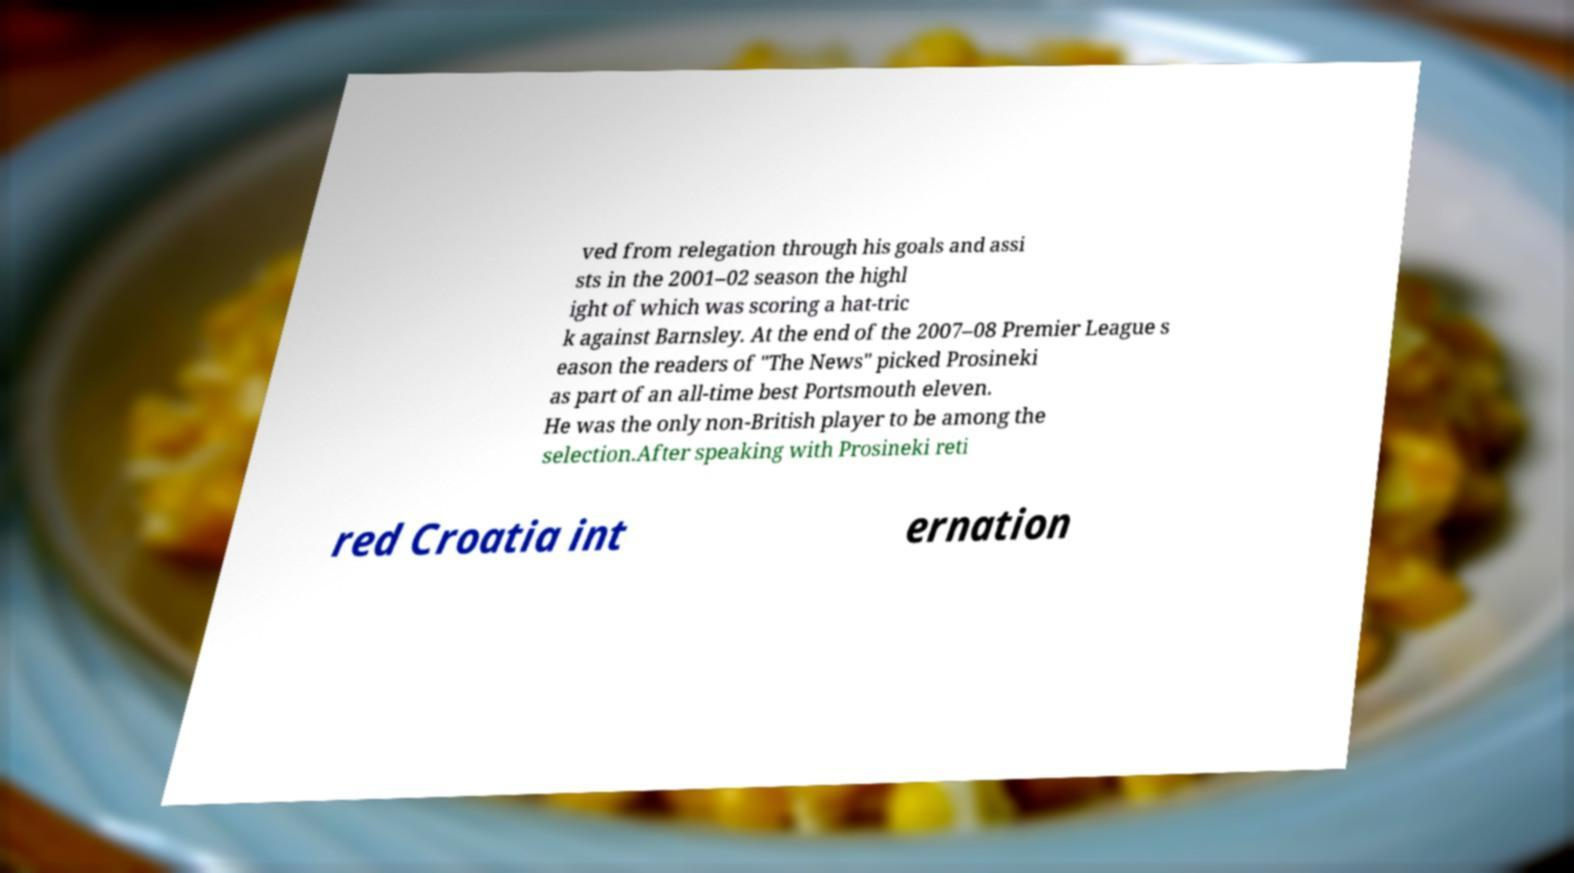Could you extract and type out the text from this image? ved from relegation through his goals and assi sts in the 2001–02 season the highl ight of which was scoring a hat-tric k against Barnsley. At the end of the 2007–08 Premier League s eason the readers of "The News" picked Prosineki as part of an all-time best Portsmouth eleven. He was the only non-British player to be among the selection.After speaking with Prosineki reti red Croatia int ernation 